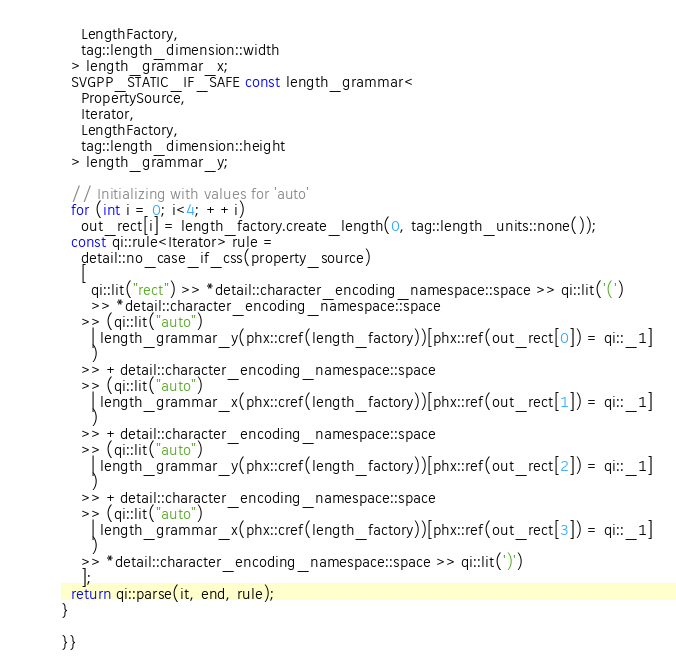Convert code to text. <code><loc_0><loc_0><loc_500><loc_500><_C++_>    LengthFactory,
    tag::length_dimension::width
  > length_grammar_x;
  SVGPP_STATIC_IF_SAFE const length_grammar<
    PropertySource,
    Iterator,
    LengthFactory,
    tag::length_dimension::height
  > length_grammar_y;

  // Initializing with values for 'auto'
  for (int i = 0; i<4; ++i)
    out_rect[i] = length_factory.create_length(0, tag::length_units::none());
  const qi::rule<Iterator> rule =
    detail::no_case_if_css(property_source)
    [
      qi::lit("rect") >> *detail::character_encoding_namespace::space >> qi::lit('(')
      >> *detail::character_encoding_namespace::space
    >> (qi::lit("auto")
      | length_grammar_y(phx::cref(length_factory))[phx::ref(out_rect[0]) = qi::_1]
      )
    >> +detail::character_encoding_namespace::space
    >> (qi::lit("auto")
      | length_grammar_x(phx::cref(length_factory))[phx::ref(out_rect[1]) = qi::_1]
      )
    >> +detail::character_encoding_namespace::space
    >> (qi::lit("auto")
      | length_grammar_y(phx::cref(length_factory))[phx::ref(out_rect[2]) = qi::_1]
      )
    >> +detail::character_encoding_namespace::space
    >> (qi::lit("auto")
      | length_grammar_x(phx::cref(length_factory))[phx::ref(out_rect[3]) = qi::_1]
      )
    >> *detail::character_encoding_namespace::space >> qi::lit(')')
    ];
  return qi::parse(it, end, rule);
}

}}</code> 